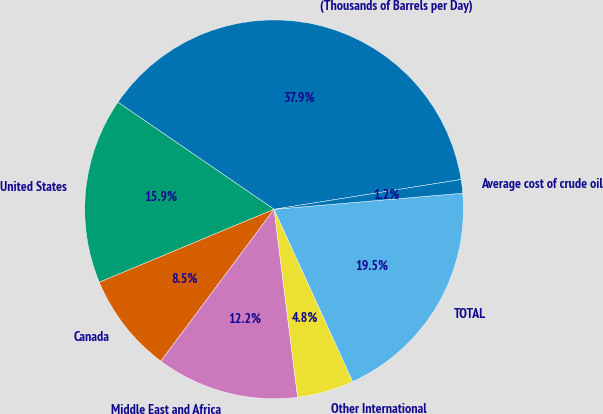Convert chart to OTSL. <chart><loc_0><loc_0><loc_500><loc_500><pie_chart><fcel>(Thousands of Barrels per Day)<fcel>United States<fcel>Canada<fcel>Middle East and Africa<fcel>Other International<fcel>TOTAL<fcel>Average cost of crude oil<nl><fcel>37.92%<fcel>15.86%<fcel>8.51%<fcel>12.18%<fcel>4.83%<fcel>19.54%<fcel>1.16%<nl></chart> 